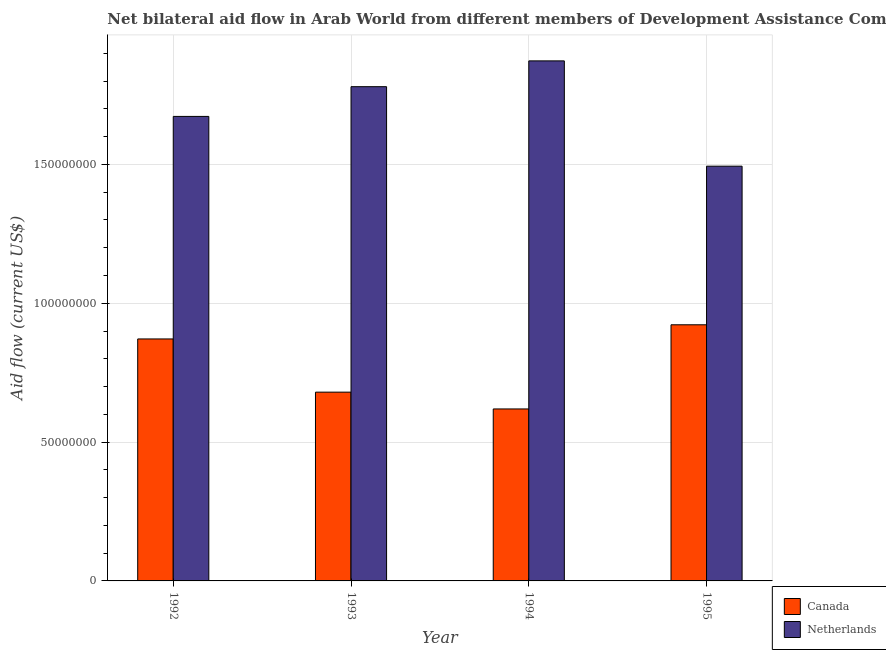Are the number of bars per tick equal to the number of legend labels?
Provide a succinct answer. Yes. Are the number of bars on each tick of the X-axis equal?
Your answer should be very brief. Yes. How many bars are there on the 4th tick from the left?
Keep it short and to the point. 2. How many bars are there on the 3rd tick from the right?
Ensure brevity in your answer.  2. What is the amount of aid given by canada in 1992?
Provide a short and direct response. 8.71e+07. Across all years, what is the maximum amount of aid given by canada?
Give a very brief answer. 9.22e+07. Across all years, what is the minimum amount of aid given by netherlands?
Give a very brief answer. 1.49e+08. In which year was the amount of aid given by canada maximum?
Make the answer very short. 1995. What is the total amount of aid given by netherlands in the graph?
Provide a short and direct response. 6.82e+08. What is the difference between the amount of aid given by canada in 1993 and that in 1995?
Offer a terse response. -2.43e+07. What is the difference between the amount of aid given by canada in 1995 and the amount of aid given by netherlands in 1994?
Give a very brief answer. 3.03e+07. What is the average amount of aid given by canada per year?
Make the answer very short. 7.73e+07. In the year 1994, what is the difference between the amount of aid given by canada and amount of aid given by netherlands?
Provide a succinct answer. 0. In how many years, is the amount of aid given by netherlands greater than 40000000 US$?
Provide a succinct answer. 4. What is the ratio of the amount of aid given by netherlands in 1992 to that in 1993?
Ensure brevity in your answer.  0.94. What is the difference between the highest and the second highest amount of aid given by canada?
Offer a very short reply. 5.10e+06. What is the difference between the highest and the lowest amount of aid given by canada?
Ensure brevity in your answer.  3.03e+07. Is the sum of the amount of aid given by netherlands in 1994 and 1995 greater than the maximum amount of aid given by canada across all years?
Your answer should be very brief. Yes. What does the 2nd bar from the left in 1994 represents?
Your answer should be compact. Netherlands. What does the 1st bar from the right in 1994 represents?
Provide a succinct answer. Netherlands. How many bars are there?
Your answer should be very brief. 8. What is the difference between two consecutive major ticks on the Y-axis?
Keep it short and to the point. 5.00e+07. Where does the legend appear in the graph?
Keep it short and to the point. Bottom right. How many legend labels are there?
Your answer should be very brief. 2. How are the legend labels stacked?
Keep it short and to the point. Vertical. What is the title of the graph?
Keep it short and to the point. Net bilateral aid flow in Arab World from different members of Development Assistance Committee. What is the label or title of the Y-axis?
Give a very brief answer. Aid flow (current US$). What is the Aid flow (current US$) in Canada in 1992?
Give a very brief answer. 8.71e+07. What is the Aid flow (current US$) in Netherlands in 1992?
Your answer should be very brief. 1.67e+08. What is the Aid flow (current US$) in Canada in 1993?
Provide a short and direct response. 6.80e+07. What is the Aid flow (current US$) of Netherlands in 1993?
Your answer should be compact. 1.78e+08. What is the Aid flow (current US$) in Canada in 1994?
Your answer should be compact. 6.19e+07. What is the Aid flow (current US$) in Netherlands in 1994?
Give a very brief answer. 1.87e+08. What is the Aid flow (current US$) in Canada in 1995?
Your response must be concise. 9.22e+07. What is the Aid flow (current US$) of Netherlands in 1995?
Keep it short and to the point. 1.49e+08. Across all years, what is the maximum Aid flow (current US$) of Canada?
Offer a terse response. 9.22e+07. Across all years, what is the maximum Aid flow (current US$) of Netherlands?
Provide a short and direct response. 1.87e+08. Across all years, what is the minimum Aid flow (current US$) in Canada?
Offer a very short reply. 6.19e+07. Across all years, what is the minimum Aid flow (current US$) in Netherlands?
Provide a succinct answer. 1.49e+08. What is the total Aid flow (current US$) of Canada in the graph?
Your answer should be very brief. 3.09e+08. What is the total Aid flow (current US$) in Netherlands in the graph?
Offer a very short reply. 6.82e+08. What is the difference between the Aid flow (current US$) of Canada in 1992 and that in 1993?
Offer a very short reply. 1.92e+07. What is the difference between the Aid flow (current US$) in Netherlands in 1992 and that in 1993?
Give a very brief answer. -1.07e+07. What is the difference between the Aid flow (current US$) of Canada in 1992 and that in 1994?
Your answer should be compact. 2.52e+07. What is the difference between the Aid flow (current US$) of Netherlands in 1992 and that in 1994?
Make the answer very short. -2.00e+07. What is the difference between the Aid flow (current US$) in Canada in 1992 and that in 1995?
Give a very brief answer. -5.10e+06. What is the difference between the Aid flow (current US$) in Netherlands in 1992 and that in 1995?
Provide a short and direct response. 1.79e+07. What is the difference between the Aid flow (current US$) in Canada in 1993 and that in 1994?
Give a very brief answer. 6.05e+06. What is the difference between the Aid flow (current US$) in Netherlands in 1993 and that in 1994?
Your answer should be very brief. -9.29e+06. What is the difference between the Aid flow (current US$) of Canada in 1993 and that in 1995?
Provide a succinct answer. -2.43e+07. What is the difference between the Aid flow (current US$) of Netherlands in 1993 and that in 1995?
Ensure brevity in your answer.  2.86e+07. What is the difference between the Aid flow (current US$) of Canada in 1994 and that in 1995?
Your response must be concise. -3.03e+07. What is the difference between the Aid flow (current US$) in Netherlands in 1994 and that in 1995?
Offer a very short reply. 3.79e+07. What is the difference between the Aid flow (current US$) of Canada in 1992 and the Aid flow (current US$) of Netherlands in 1993?
Ensure brevity in your answer.  -9.08e+07. What is the difference between the Aid flow (current US$) of Canada in 1992 and the Aid flow (current US$) of Netherlands in 1994?
Give a very brief answer. -1.00e+08. What is the difference between the Aid flow (current US$) in Canada in 1992 and the Aid flow (current US$) in Netherlands in 1995?
Your answer should be compact. -6.22e+07. What is the difference between the Aid flow (current US$) in Canada in 1993 and the Aid flow (current US$) in Netherlands in 1994?
Offer a very short reply. -1.19e+08. What is the difference between the Aid flow (current US$) of Canada in 1993 and the Aid flow (current US$) of Netherlands in 1995?
Offer a very short reply. -8.14e+07. What is the difference between the Aid flow (current US$) in Canada in 1994 and the Aid flow (current US$) in Netherlands in 1995?
Offer a very short reply. -8.74e+07. What is the average Aid flow (current US$) of Canada per year?
Offer a terse response. 7.73e+07. What is the average Aid flow (current US$) in Netherlands per year?
Give a very brief answer. 1.70e+08. In the year 1992, what is the difference between the Aid flow (current US$) in Canada and Aid flow (current US$) in Netherlands?
Make the answer very short. -8.01e+07. In the year 1993, what is the difference between the Aid flow (current US$) in Canada and Aid flow (current US$) in Netherlands?
Give a very brief answer. -1.10e+08. In the year 1994, what is the difference between the Aid flow (current US$) in Canada and Aid flow (current US$) in Netherlands?
Provide a short and direct response. -1.25e+08. In the year 1995, what is the difference between the Aid flow (current US$) of Canada and Aid flow (current US$) of Netherlands?
Your response must be concise. -5.71e+07. What is the ratio of the Aid flow (current US$) in Canada in 1992 to that in 1993?
Keep it short and to the point. 1.28. What is the ratio of the Aid flow (current US$) in Netherlands in 1992 to that in 1993?
Provide a succinct answer. 0.94. What is the ratio of the Aid flow (current US$) of Canada in 1992 to that in 1994?
Offer a terse response. 1.41. What is the ratio of the Aid flow (current US$) of Netherlands in 1992 to that in 1994?
Your response must be concise. 0.89. What is the ratio of the Aid flow (current US$) in Canada in 1992 to that in 1995?
Your response must be concise. 0.94. What is the ratio of the Aid flow (current US$) of Netherlands in 1992 to that in 1995?
Provide a succinct answer. 1.12. What is the ratio of the Aid flow (current US$) in Canada in 1993 to that in 1994?
Offer a terse response. 1.1. What is the ratio of the Aid flow (current US$) of Netherlands in 1993 to that in 1994?
Your answer should be compact. 0.95. What is the ratio of the Aid flow (current US$) in Canada in 1993 to that in 1995?
Your answer should be very brief. 0.74. What is the ratio of the Aid flow (current US$) of Netherlands in 1993 to that in 1995?
Provide a succinct answer. 1.19. What is the ratio of the Aid flow (current US$) of Canada in 1994 to that in 1995?
Give a very brief answer. 0.67. What is the ratio of the Aid flow (current US$) in Netherlands in 1994 to that in 1995?
Make the answer very short. 1.25. What is the difference between the highest and the second highest Aid flow (current US$) of Canada?
Make the answer very short. 5.10e+06. What is the difference between the highest and the second highest Aid flow (current US$) in Netherlands?
Ensure brevity in your answer.  9.29e+06. What is the difference between the highest and the lowest Aid flow (current US$) in Canada?
Your answer should be very brief. 3.03e+07. What is the difference between the highest and the lowest Aid flow (current US$) of Netherlands?
Provide a short and direct response. 3.79e+07. 